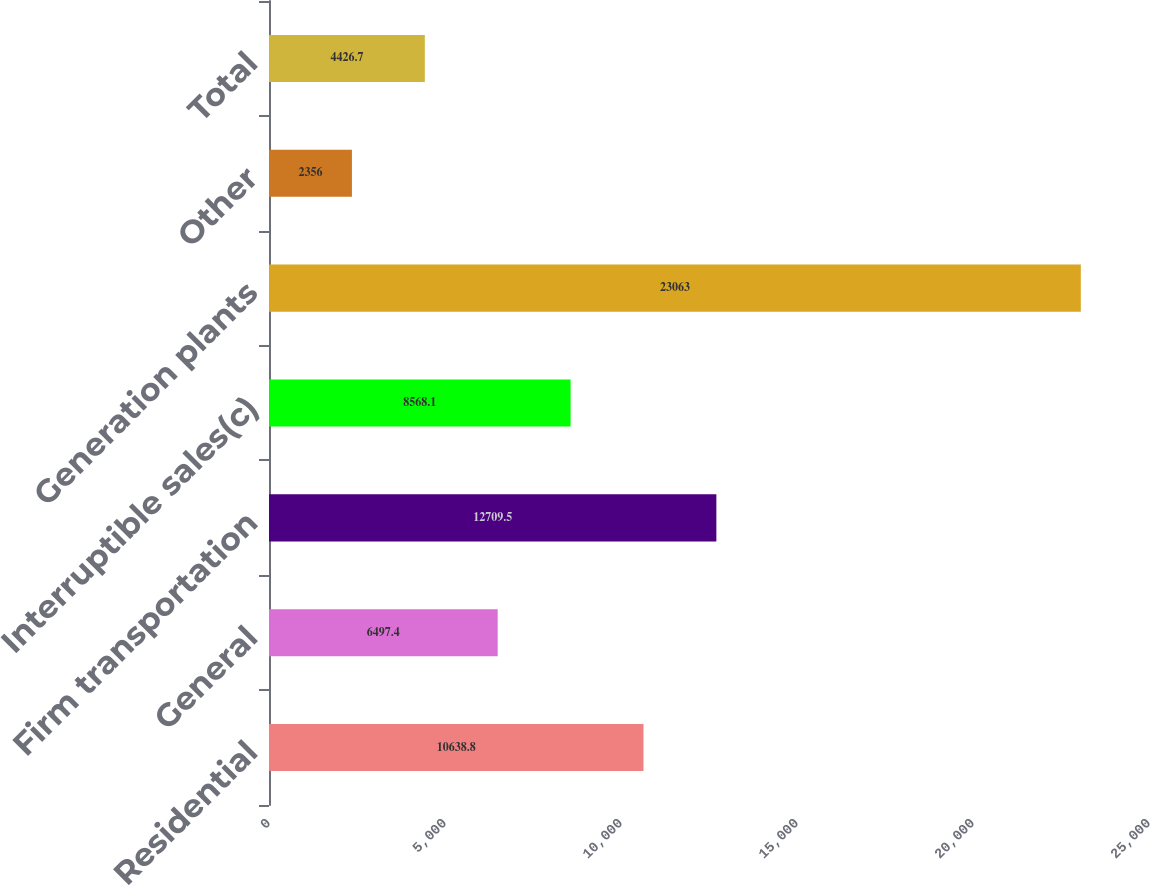Convert chart. <chart><loc_0><loc_0><loc_500><loc_500><bar_chart><fcel>Residential<fcel>General<fcel>Firm transportation<fcel>Interruptible sales(c)<fcel>Generation plants<fcel>Other<fcel>Total<nl><fcel>10638.8<fcel>6497.4<fcel>12709.5<fcel>8568.1<fcel>23063<fcel>2356<fcel>4426.7<nl></chart> 